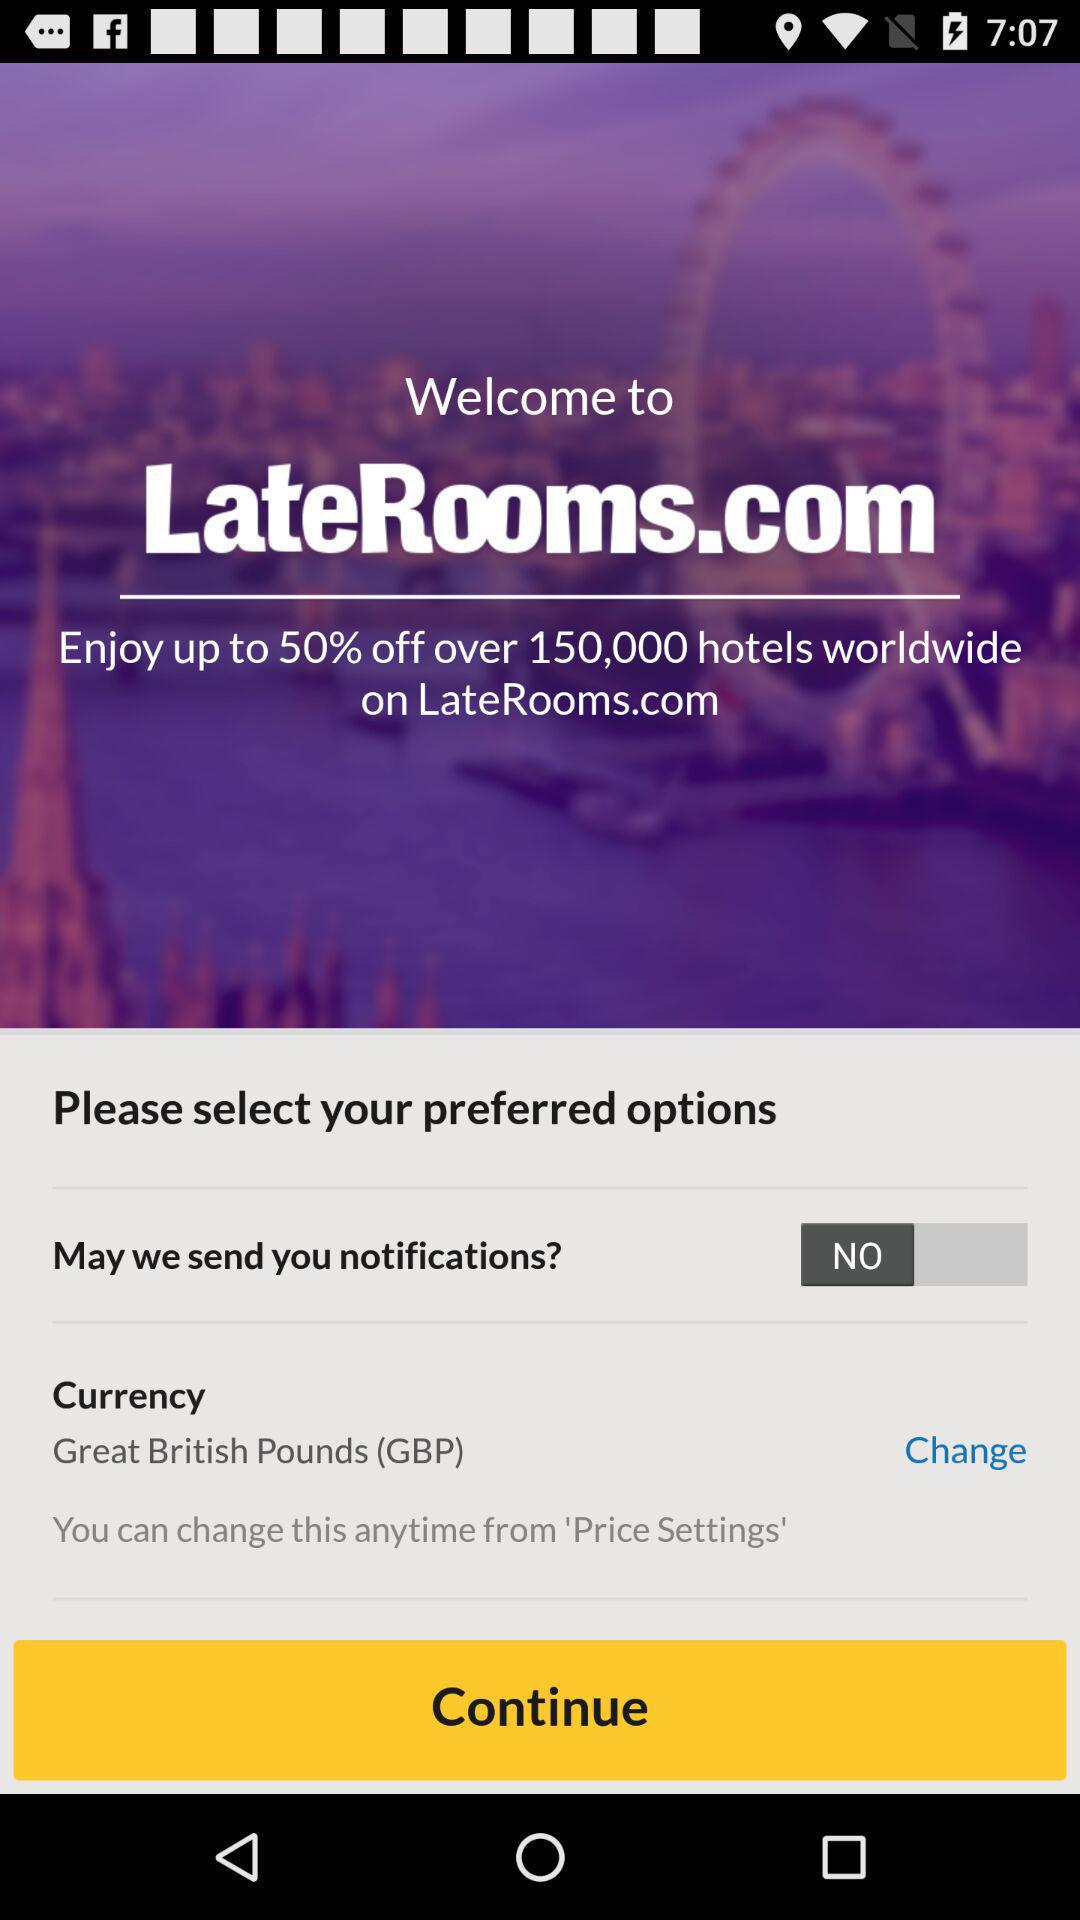How many hotels worldwide are on LateRooms.com? There are over 150,000 hotels worldwide on LateRooms.com. 